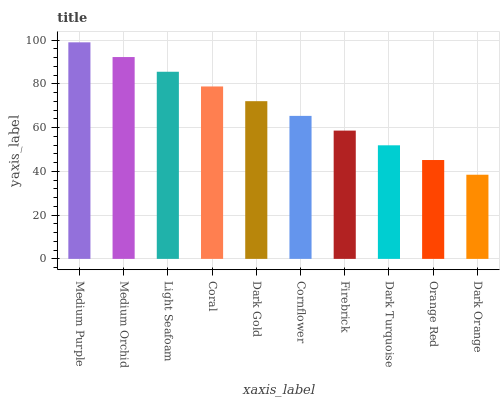Is Dark Orange the minimum?
Answer yes or no. Yes. Is Medium Purple the maximum?
Answer yes or no. Yes. Is Medium Orchid the minimum?
Answer yes or no. No. Is Medium Orchid the maximum?
Answer yes or no. No. Is Medium Purple greater than Medium Orchid?
Answer yes or no. Yes. Is Medium Orchid less than Medium Purple?
Answer yes or no. Yes. Is Medium Orchid greater than Medium Purple?
Answer yes or no. No. Is Medium Purple less than Medium Orchid?
Answer yes or no. No. Is Dark Gold the high median?
Answer yes or no. Yes. Is Cornflower the low median?
Answer yes or no. Yes. Is Orange Red the high median?
Answer yes or no. No. Is Dark Orange the low median?
Answer yes or no. No. 